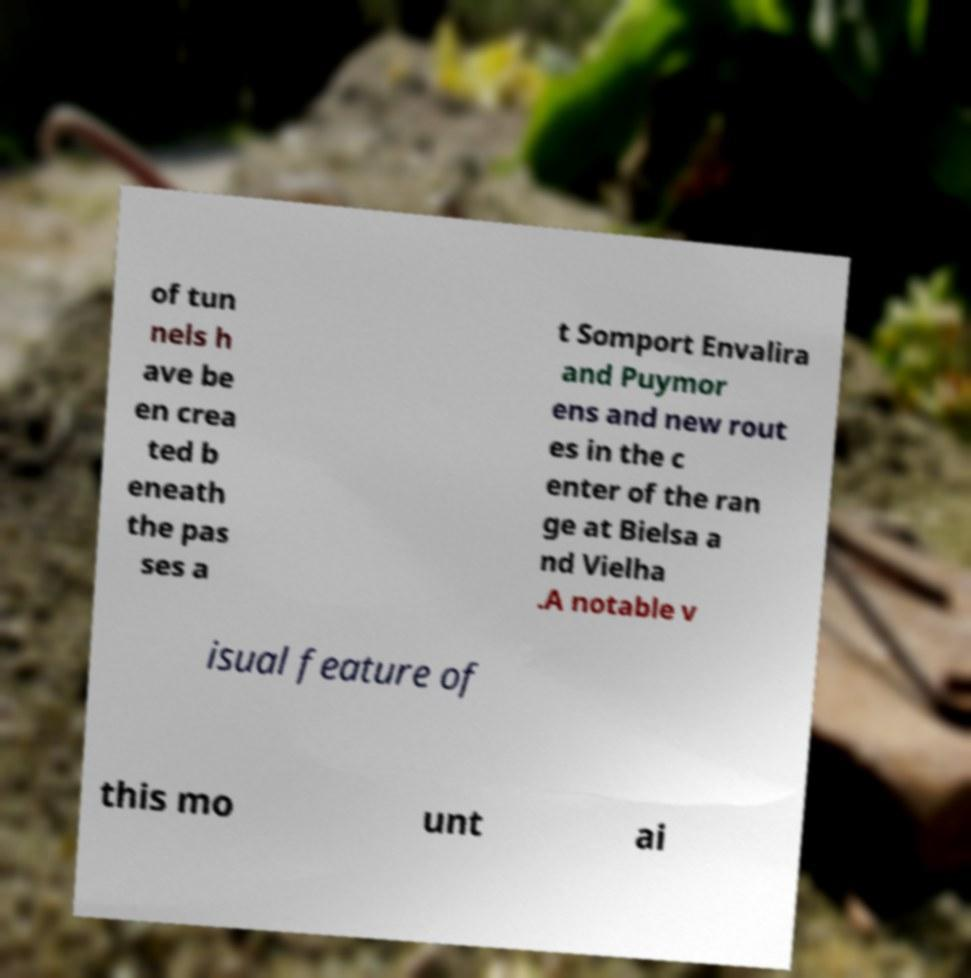Can you accurately transcribe the text from the provided image for me? of tun nels h ave be en crea ted b eneath the pas ses a t Somport Envalira and Puymor ens and new rout es in the c enter of the ran ge at Bielsa a nd Vielha .A notable v isual feature of this mo unt ai 